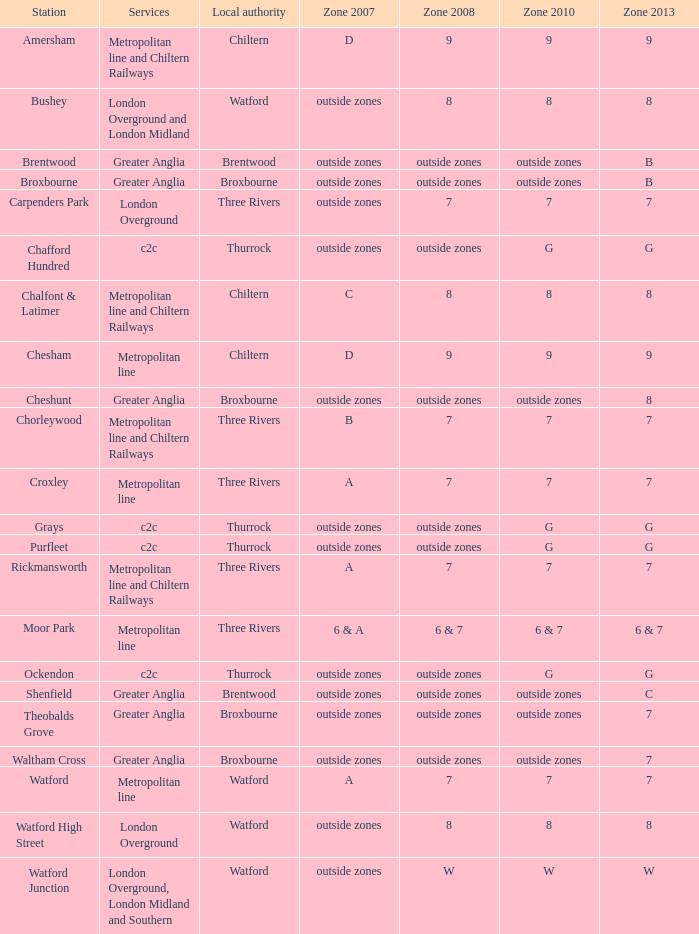Which Services have a Local authority of chiltern, and a Zone 2010 of 9? Metropolitan line and Chiltern Railways, Metropolitan line. 